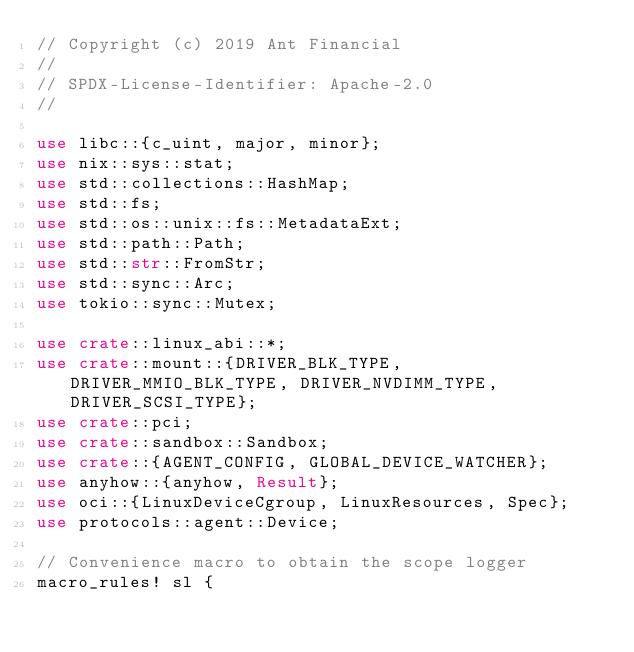<code> <loc_0><loc_0><loc_500><loc_500><_Rust_>// Copyright (c) 2019 Ant Financial
//
// SPDX-License-Identifier: Apache-2.0
//

use libc::{c_uint, major, minor};
use nix::sys::stat;
use std::collections::HashMap;
use std::fs;
use std::os::unix::fs::MetadataExt;
use std::path::Path;
use std::str::FromStr;
use std::sync::Arc;
use tokio::sync::Mutex;

use crate::linux_abi::*;
use crate::mount::{DRIVER_BLK_TYPE, DRIVER_MMIO_BLK_TYPE, DRIVER_NVDIMM_TYPE, DRIVER_SCSI_TYPE};
use crate::pci;
use crate::sandbox::Sandbox;
use crate::{AGENT_CONFIG, GLOBAL_DEVICE_WATCHER};
use anyhow::{anyhow, Result};
use oci::{LinuxDeviceCgroup, LinuxResources, Spec};
use protocols::agent::Device;

// Convenience macro to obtain the scope logger
macro_rules! sl {</code> 